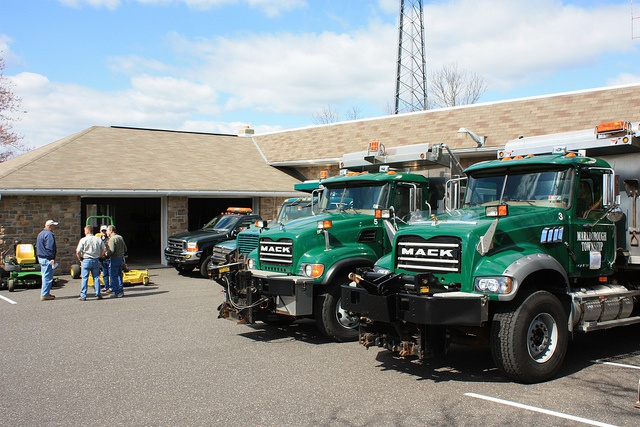Describe the objects in this image and their specific colors. I can see truck in lightblue, black, gray, teal, and lightgray tones, truck in lightblue, black, teal, gray, and lightgray tones, truck in lightblue, black, gray, darkgray, and blue tones, car in lightblue, black, gray, blue, and darkgray tones, and people in lightblue, white, gray, and navy tones in this image. 